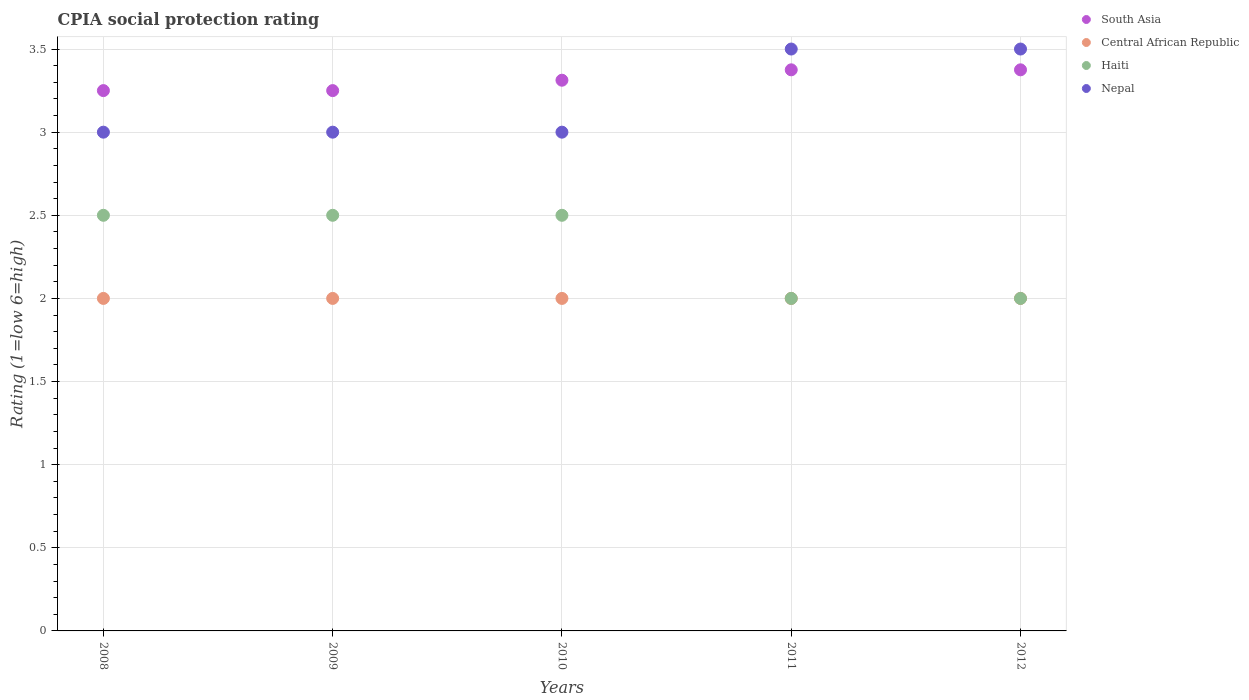How many different coloured dotlines are there?
Your answer should be compact. 4. What is the CPIA rating in Nepal in 2008?
Provide a short and direct response. 3. Across all years, what is the maximum CPIA rating in Nepal?
Offer a terse response. 3.5. Across all years, what is the minimum CPIA rating in Central African Republic?
Offer a terse response. 2. In which year was the CPIA rating in South Asia maximum?
Keep it short and to the point. 2011. In which year was the CPIA rating in Central African Republic minimum?
Keep it short and to the point. 2008. What is the total CPIA rating in Haiti in the graph?
Keep it short and to the point. 11.5. What is the difference between the CPIA rating in Haiti in 2010 and that in 2011?
Provide a short and direct response. 0.5. What is the average CPIA rating in Central African Republic per year?
Provide a succinct answer. 2. In the year 2010, what is the difference between the CPIA rating in Nepal and CPIA rating in South Asia?
Provide a short and direct response. -0.31. What is the ratio of the CPIA rating in Central African Republic in 2008 to that in 2011?
Give a very brief answer. 1. Is the CPIA rating in Central African Republic in 2008 less than that in 2009?
Your answer should be compact. No. What is the difference between the highest and the second highest CPIA rating in Nepal?
Offer a terse response. 0. Is the sum of the CPIA rating in Central African Republic in 2009 and 2012 greater than the maximum CPIA rating in Haiti across all years?
Give a very brief answer. Yes. Is it the case that in every year, the sum of the CPIA rating in South Asia and CPIA rating in Nepal  is greater than the sum of CPIA rating in Central African Republic and CPIA rating in Haiti?
Give a very brief answer. No. How many dotlines are there?
Your answer should be compact. 4. How many years are there in the graph?
Your answer should be compact. 5. Are the values on the major ticks of Y-axis written in scientific E-notation?
Offer a very short reply. No. Does the graph contain grids?
Your response must be concise. Yes. Where does the legend appear in the graph?
Ensure brevity in your answer.  Top right. What is the title of the graph?
Your answer should be compact. CPIA social protection rating. What is the Rating (1=low 6=high) in South Asia in 2008?
Provide a short and direct response. 3.25. What is the Rating (1=low 6=high) of Central African Republic in 2008?
Make the answer very short. 2. What is the Rating (1=low 6=high) of Nepal in 2008?
Offer a terse response. 3. What is the Rating (1=low 6=high) in South Asia in 2010?
Your answer should be compact. 3.31. What is the Rating (1=low 6=high) in Haiti in 2010?
Provide a succinct answer. 2.5. What is the Rating (1=low 6=high) in South Asia in 2011?
Give a very brief answer. 3.38. What is the Rating (1=low 6=high) in Central African Republic in 2011?
Your response must be concise. 2. What is the Rating (1=low 6=high) in South Asia in 2012?
Give a very brief answer. 3.38. What is the Rating (1=low 6=high) of Nepal in 2012?
Your answer should be compact. 3.5. Across all years, what is the maximum Rating (1=low 6=high) of South Asia?
Give a very brief answer. 3.38. Across all years, what is the maximum Rating (1=low 6=high) of Nepal?
Your response must be concise. 3.5. Across all years, what is the minimum Rating (1=low 6=high) in Nepal?
Ensure brevity in your answer.  3. What is the total Rating (1=low 6=high) in South Asia in the graph?
Your answer should be compact. 16.56. What is the total Rating (1=low 6=high) in Central African Republic in the graph?
Provide a short and direct response. 10. What is the difference between the Rating (1=low 6=high) of South Asia in 2008 and that in 2009?
Offer a very short reply. 0. What is the difference between the Rating (1=low 6=high) in Central African Republic in 2008 and that in 2009?
Your response must be concise. 0. What is the difference between the Rating (1=low 6=high) of Nepal in 2008 and that in 2009?
Your answer should be compact. 0. What is the difference between the Rating (1=low 6=high) in South Asia in 2008 and that in 2010?
Give a very brief answer. -0.06. What is the difference between the Rating (1=low 6=high) in Central African Republic in 2008 and that in 2010?
Offer a terse response. 0. What is the difference between the Rating (1=low 6=high) of South Asia in 2008 and that in 2011?
Offer a very short reply. -0.12. What is the difference between the Rating (1=low 6=high) of Central African Republic in 2008 and that in 2011?
Keep it short and to the point. 0. What is the difference between the Rating (1=low 6=high) in South Asia in 2008 and that in 2012?
Keep it short and to the point. -0.12. What is the difference between the Rating (1=low 6=high) of Central African Republic in 2008 and that in 2012?
Your answer should be very brief. 0. What is the difference between the Rating (1=low 6=high) in Haiti in 2008 and that in 2012?
Provide a succinct answer. 0.5. What is the difference between the Rating (1=low 6=high) of South Asia in 2009 and that in 2010?
Make the answer very short. -0.06. What is the difference between the Rating (1=low 6=high) of Central African Republic in 2009 and that in 2010?
Offer a very short reply. 0. What is the difference between the Rating (1=low 6=high) in Nepal in 2009 and that in 2010?
Make the answer very short. 0. What is the difference between the Rating (1=low 6=high) of South Asia in 2009 and that in 2011?
Make the answer very short. -0.12. What is the difference between the Rating (1=low 6=high) in Haiti in 2009 and that in 2011?
Make the answer very short. 0.5. What is the difference between the Rating (1=low 6=high) of Nepal in 2009 and that in 2011?
Your answer should be compact. -0.5. What is the difference between the Rating (1=low 6=high) of South Asia in 2009 and that in 2012?
Your response must be concise. -0.12. What is the difference between the Rating (1=low 6=high) in Central African Republic in 2009 and that in 2012?
Make the answer very short. 0. What is the difference between the Rating (1=low 6=high) of Haiti in 2009 and that in 2012?
Keep it short and to the point. 0.5. What is the difference between the Rating (1=low 6=high) of South Asia in 2010 and that in 2011?
Offer a very short reply. -0.06. What is the difference between the Rating (1=low 6=high) of Central African Republic in 2010 and that in 2011?
Make the answer very short. 0. What is the difference between the Rating (1=low 6=high) of South Asia in 2010 and that in 2012?
Your answer should be very brief. -0.06. What is the difference between the Rating (1=low 6=high) in South Asia in 2011 and that in 2012?
Give a very brief answer. 0. What is the difference between the Rating (1=low 6=high) in Central African Republic in 2011 and that in 2012?
Provide a short and direct response. 0. What is the difference between the Rating (1=low 6=high) of Haiti in 2011 and that in 2012?
Your response must be concise. 0. What is the difference between the Rating (1=low 6=high) in Central African Republic in 2008 and the Rating (1=low 6=high) in Haiti in 2009?
Your answer should be compact. -0.5. What is the difference between the Rating (1=low 6=high) of South Asia in 2008 and the Rating (1=low 6=high) of Central African Republic in 2010?
Your answer should be very brief. 1.25. What is the difference between the Rating (1=low 6=high) of South Asia in 2008 and the Rating (1=low 6=high) of Haiti in 2010?
Your response must be concise. 0.75. What is the difference between the Rating (1=low 6=high) of South Asia in 2008 and the Rating (1=low 6=high) of Nepal in 2010?
Make the answer very short. 0.25. What is the difference between the Rating (1=low 6=high) of Central African Republic in 2008 and the Rating (1=low 6=high) of Haiti in 2010?
Offer a terse response. -0.5. What is the difference between the Rating (1=low 6=high) of South Asia in 2008 and the Rating (1=low 6=high) of Haiti in 2011?
Provide a succinct answer. 1.25. What is the difference between the Rating (1=low 6=high) in South Asia in 2008 and the Rating (1=low 6=high) in Nepal in 2011?
Your answer should be very brief. -0.25. What is the difference between the Rating (1=low 6=high) in Central African Republic in 2008 and the Rating (1=low 6=high) in Haiti in 2011?
Keep it short and to the point. 0. What is the difference between the Rating (1=low 6=high) in South Asia in 2008 and the Rating (1=low 6=high) in Haiti in 2012?
Your answer should be compact. 1.25. What is the difference between the Rating (1=low 6=high) of South Asia in 2009 and the Rating (1=low 6=high) of Haiti in 2010?
Ensure brevity in your answer.  0.75. What is the difference between the Rating (1=low 6=high) of Central African Republic in 2009 and the Rating (1=low 6=high) of Haiti in 2010?
Offer a very short reply. -0.5. What is the difference between the Rating (1=low 6=high) in South Asia in 2009 and the Rating (1=low 6=high) in Haiti in 2011?
Make the answer very short. 1.25. What is the difference between the Rating (1=low 6=high) in South Asia in 2009 and the Rating (1=low 6=high) in Nepal in 2011?
Your answer should be compact. -0.25. What is the difference between the Rating (1=low 6=high) in Haiti in 2009 and the Rating (1=low 6=high) in Nepal in 2011?
Your answer should be very brief. -1. What is the difference between the Rating (1=low 6=high) of Haiti in 2009 and the Rating (1=low 6=high) of Nepal in 2012?
Offer a terse response. -1. What is the difference between the Rating (1=low 6=high) of South Asia in 2010 and the Rating (1=low 6=high) of Central African Republic in 2011?
Offer a terse response. 1.31. What is the difference between the Rating (1=low 6=high) in South Asia in 2010 and the Rating (1=low 6=high) in Haiti in 2011?
Your response must be concise. 1.31. What is the difference between the Rating (1=low 6=high) in South Asia in 2010 and the Rating (1=low 6=high) in Nepal in 2011?
Your response must be concise. -0.19. What is the difference between the Rating (1=low 6=high) in Haiti in 2010 and the Rating (1=low 6=high) in Nepal in 2011?
Your response must be concise. -1. What is the difference between the Rating (1=low 6=high) in South Asia in 2010 and the Rating (1=low 6=high) in Central African Republic in 2012?
Provide a succinct answer. 1.31. What is the difference between the Rating (1=low 6=high) in South Asia in 2010 and the Rating (1=low 6=high) in Haiti in 2012?
Ensure brevity in your answer.  1.31. What is the difference between the Rating (1=low 6=high) of South Asia in 2010 and the Rating (1=low 6=high) of Nepal in 2012?
Your answer should be compact. -0.19. What is the difference between the Rating (1=low 6=high) of Haiti in 2010 and the Rating (1=low 6=high) of Nepal in 2012?
Offer a terse response. -1. What is the difference between the Rating (1=low 6=high) of South Asia in 2011 and the Rating (1=low 6=high) of Central African Republic in 2012?
Your response must be concise. 1.38. What is the difference between the Rating (1=low 6=high) in South Asia in 2011 and the Rating (1=low 6=high) in Haiti in 2012?
Your answer should be compact. 1.38. What is the difference between the Rating (1=low 6=high) in South Asia in 2011 and the Rating (1=low 6=high) in Nepal in 2012?
Your answer should be compact. -0.12. What is the difference between the Rating (1=low 6=high) of Central African Republic in 2011 and the Rating (1=low 6=high) of Haiti in 2012?
Make the answer very short. 0. What is the average Rating (1=low 6=high) of South Asia per year?
Offer a very short reply. 3.31. What is the average Rating (1=low 6=high) in Central African Republic per year?
Provide a succinct answer. 2. What is the average Rating (1=low 6=high) of Nepal per year?
Offer a very short reply. 3.2. In the year 2008, what is the difference between the Rating (1=low 6=high) of South Asia and Rating (1=low 6=high) of Haiti?
Keep it short and to the point. 0.75. In the year 2008, what is the difference between the Rating (1=low 6=high) of South Asia and Rating (1=low 6=high) of Nepal?
Provide a short and direct response. 0.25. In the year 2008, what is the difference between the Rating (1=low 6=high) in Central African Republic and Rating (1=low 6=high) in Haiti?
Keep it short and to the point. -0.5. In the year 2008, what is the difference between the Rating (1=low 6=high) of Central African Republic and Rating (1=low 6=high) of Nepal?
Give a very brief answer. -1. In the year 2009, what is the difference between the Rating (1=low 6=high) in South Asia and Rating (1=low 6=high) in Nepal?
Your answer should be very brief. 0.25. In the year 2009, what is the difference between the Rating (1=low 6=high) in Central African Republic and Rating (1=low 6=high) in Haiti?
Make the answer very short. -0.5. In the year 2010, what is the difference between the Rating (1=low 6=high) of South Asia and Rating (1=low 6=high) of Central African Republic?
Offer a terse response. 1.31. In the year 2010, what is the difference between the Rating (1=low 6=high) of South Asia and Rating (1=low 6=high) of Haiti?
Make the answer very short. 0.81. In the year 2010, what is the difference between the Rating (1=low 6=high) in South Asia and Rating (1=low 6=high) in Nepal?
Your answer should be compact. 0.31. In the year 2010, what is the difference between the Rating (1=low 6=high) of Central African Republic and Rating (1=low 6=high) of Haiti?
Ensure brevity in your answer.  -0.5. In the year 2010, what is the difference between the Rating (1=low 6=high) of Central African Republic and Rating (1=low 6=high) of Nepal?
Keep it short and to the point. -1. In the year 2010, what is the difference between the Rating (1=low 6=high) in Haiti and Rating (1=low 6=high) in Nepal?
Your answer should be very brief. -0.5. In the year 2011, what is the difference between the Rating (1=low 6=high) in South Asia and Rating (1=low 6=high) in Central African Republic?
Make the answer very short. 1.38. In the year 2011, what is the difference between the Rating (1=low 6=high) in South Asia and Rating (1=low 6=high) in Haiti?
Offer a terse response. 1.38. In the year 2011, what is the difference between the Rating (1=low 6=high) in South Asia and Rating (1=low 6=high) in Nepal?
Your answer should be very brief. -0.12. In the year 2011, what is the difference between the Rating (1=low 6=high) of Central African Republic and Rating (1=low 6=high) of Haiti?
Make the answer very short. 0. In the year 2011, what is the difference between the Rating (1=low 6=high) of Central African Republic and Rating (1=low 6=high) of Nepal?
Offer a terse response. -1.5. In the year 2012, what is the difference between the Rating (1=low 6=high) in South Asia and Rating (1=low 6=high) in Central African Republic?
Provide a short and direct response. 1.38. In the year 2012, what is the difference between the Rating (1=low 6=high) of South Asia and Rating (1=low 6=high) of Haiti?
Your response must be concise. 1.38. In the year 2012, what is the difference between the Rating (1=low 6=high) of South Asia and Rating (1=low 6=high) of Nepal?
Ensure brevity in your answer.  -0.12. In the year 2012, what is the difference between the Rating (1=low 6=high) of Central African Republic and Rating (1=low 6=high) of Nepal?
Ensure brevity in your answer.  -1.5. What is the ratio of the Rating (1=low 6=high) of Central African Republic in 2008 to that in 2009?
Offer a terse response. 1. What is the ratio of the Rating (1=low 6=high) of Haiti in 2008 to that in 2009?
Your answer should be very brief. 1. What is the ratio of the Rating (1=low 6=high) in Nepal in 2008 to that in 2009?
Offer a very short reply. 1. What is the ratio of the Rating (1=low 6=high) in South Asia in 2008 to that in 2010?
Offer a terse response. 0.98. What is the ratio of the Rating (1=low 6=high) in South Asia in 2008 to that in 2011?
Offer a terse response. 0.96. What is the ratio of the Rating (1=low 6=high) of Nepal in 2008 to that in 2011?
Provide a short and direct response. 0.86. What is the ratio of the Rating (1=low 6=high) of South Asia in 2008 to that in 2012?
Your response must be concise. 0.96. What is the ratio of the Rating (1=low 6=high) of Haiti in 2008 to that in 2012?
Provide a succinct answer. 1.25. What is the ratio of the Rating (1=low 6=high) in Nepal in 2008 to that in 2012?
Provide a short and direct response. 0.86. What is the ratio of the Rating (1=low 6=high) in South Asia in 2009 to that in 2010?
Give a very brief answer. 0.98. What is the ratio of the Rating (1=low 6=high) in Central African Republic in 2009 to that in 2011?
Keep it short and to the point. 1. What is the ratio of the Rating (1=low 6=high) of Haiti in 2009 to that in 2011?
Ensure brevity in your answer.  1.25. What is the ratio of the Rating (1=low 6=high) of South Asia in 2009 to that in 2012?
Offer a terse response. 0.96. What is the ratio of the Rating (1=low 6=high) of Central African Republic in 2009 to that in 2012?
Your answer should be compact. 1. What is the ratio of the Rating (1=low 6=high) in Haiti in 2009 to that in 2012?
Make the answer very short. 1.25. What is the ratio of the Rating (1=low 6=high) in Nepal in 2009 to that in 2012?
Your answer should be very brief. 0.86. What is the ratio of the Rating (1=low 6=high) of South Asia in 2010 to that in 2011?
Your answer should be compact. 0.98. What is the ratio of the Rating (1=low 6=high) in Central African Republic in 2010 to that in 2011?
Your response must be concise. 1. What is the ratio of the Rating (1=low 6=high) of South Asia in 2010 to that in 2012?
Keep it short and to the point. 0.98. What is the ratio of the Rating (1=low 6=high) in Central African Republic in 2010 to that in 2012?
Offer a terse response. 1. What is the ratio of the Rating (1=low 6=high) of Nepal in 2010 to that in 2012?
Your response must be concise. 0.86. What is the ratio of the Rating (1=low 6=high) of Central African Republic in 2011 to that in 2012?
Your answer should be compact. 1. What is the ratio of the Rating (1=low 6=high) in Nepal in 2011 to that in 2012?
Your answer should be very brief. 1. What is the difference between the highest and the second highest Rating (1=low 6=high) of South Asia?
Keep it short and to the point. 0. What is the difference between the highest and the second highest Rating (1=low 6=high) of Haiti?
Your response must be concise. 0. What is the difference between the highest and the lowest Rating (1=low 6=high) of Central African Republic?
Offer a very short reply. 0. What is the difference between the highest and the lowest Rating (1=low 6=high) of Haiti?
Provide a short and direct response. 0.5. What is the difference between the highest and the lowest Rating (1=low 6=high) of Nepal?
Offer a very short reply. 0.5. 